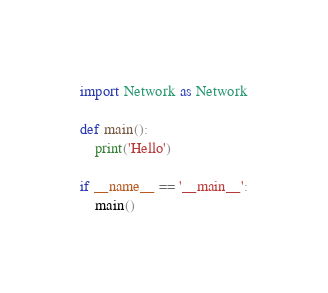<code> <loc_0><loc_0><loc_500><loc_500><_Python_>import Network as Network

def main():
    print('Hello')

if __name__ == '__main__':
    main()</code> 